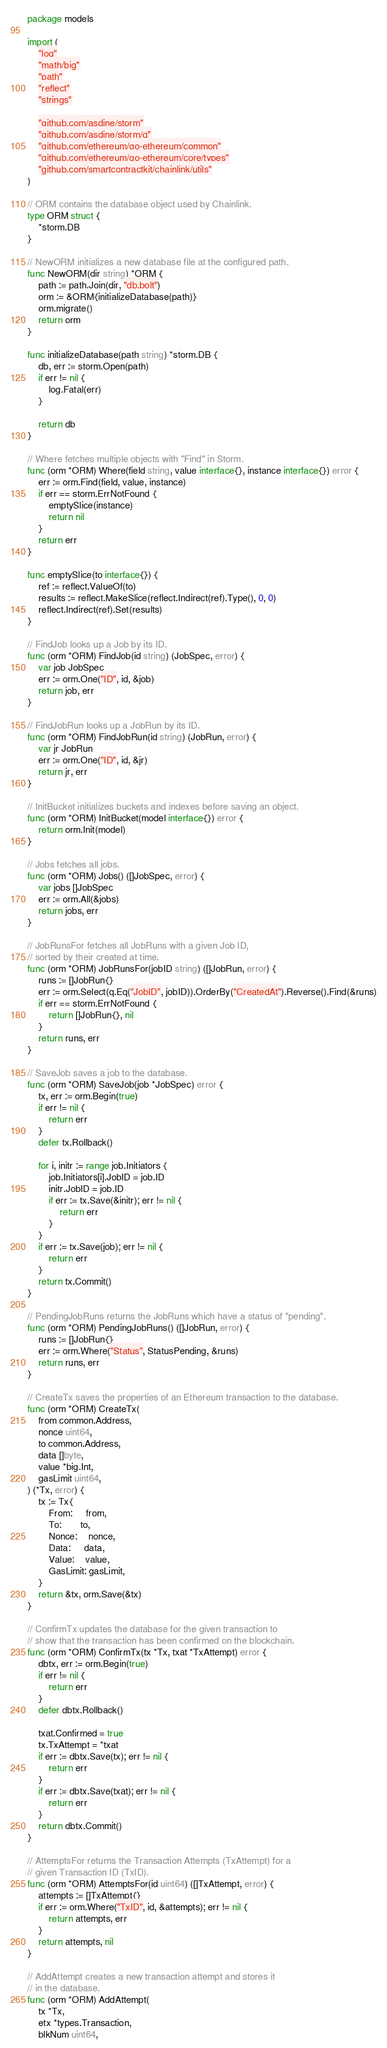Convert code to text. <code><loc_0><loc_0><loc_500><loc_500><_Go_>package models

import (
	"log"
	"math/big"
	"path"
	"reflect"
	"strings"

	"github.com/asdine/storm"
	"github.com/asdine/storm/q"
	"github.com/ethereum/go-ethereum/common"
	"github.com/ethereum/go-ethereum/core/types"
	"github.com/smartcontractkit/chainlink/utils"
)

// ORM contains the database object used by Chainlink.
type ORM struct {
	*storm.DB
}

// NewORM initializes a new database file at the configured path.
func NewORM(dir string) *ORM {
	path := path.Join(dir, "db.bolt")
	orm := &ORM{initializeDatabase(path)}
	orm.migrate()
	return orm
}

func initializeDatabase(path string) *storm.DB {
	db, err := storm.Open(path)
	if err != nil {
		log.Fatal(err)
	}

	return db
}

// Where fetches multiple objects with "Find" in Storm.
func (orm *ORM) Where(field string, value interface{}, instance interface{}) error {
	err := orm.Find(field, value, instance)
	if err == storm.ErrNotFound {
		emptySlice(instance)
		return nil
	}
	return err
}

func emptySlice(to interface{}) {
	ref := reflect.ValueOf(to)
	results := reflect.MakeSlice(reflect.Indirect(ref).Type(), 0, 0)
	reflect.Indirect(ref).Set(results)
}

// FindJob looks up a Job by its ID.
func (orm *ORM) FindJob(id string) (JobSpec, error) {
	var job JobSpec
	err := orm.One("ID", id, &job)
	return job, err
}

// FindJobRun looks up a JobRun by its ID.
func (orm *ORM) FindJobRun(id string) (JobRun, error) {
	var jr JobRun
	err := orm.One("ID", id, &jr)
	return jr, err
}

// InitBucket initializes buckets and indexes before saving an object.
func (orm *ORM) InitBucket(model interface{}) error {
	return orm.Init(model)
}

// Jobs fetches all jobs.
func (orm *ORM) Jobs() ([]JobSpec, error) {
	var jobs []JobSpec
	err := orm.All(&jobs)
	return jobs, err
}

// JobRunsFor fetches all JobRuns with a given Job ID,
// sorted by their created at time.
func (orm *ORM) JobRunsFor(jobID string) ([]JobRun, error) {
	runs := []JobRun{}
	err := orm.Select(q.Eq("JobID", jobID)).OrderBy("CreatedAt").Reverse().Find(&runs)
	if err == storm.ErrNotFound {
		return []JobRun{}, nil
	}
	return runs, err
}

// SaveJob saves a job to the database.
func (orm *ORM) SaveJob(job *JobSpec) error {
	tx, err := orm.Begin(true)
	if err != nil {
		return err
	}
	defer tx.Rollback()

	for i, initr := range job.Initiators {
		job.Initiators[i].JobID = job.ID
		initr.JobID = job.ID
		if err := tx.Save(&initr); err != nil {
			return err
		}
	}
	if err := tx.Save(job); err != nil {
		return err
	}
	return tx.Commit()
}

// PendingJobRuns returns the JobRuns which have a status of "pending".
func (orm *ORM) PendingJobRuns() ([]JobRun, error) {
	runs := []JobRun{}
	err := orm.Where("Status", StatusPending, &runs)
	return runs, err
}

// CreateTx saves the properties of an Ethereum transaction to the database.
func (orm *ORM) CreateTx(
	from common.Address,
	nonce uint64,
	to common.Address,
	data []byte,
	value *big.Int,
	gasLimit uint64,
) (*Tx, error) {
	tx := Tx{
		From:     from,
		To:       to,
		Nonce:    nonce,
		Data:     data,
		Value:    value,
		GasLimit: gasLimit,
	}
	return &tx, orm.Save(&tx)
}

// ConfirmTx updates the database for the given transaction to
// show that the transaction has been confirmed on the blockchain.
func (orm *ORM) ConfirmTx(tx *Tx, txat *TxAttempt) error {
	dbtx, err := orm.Begin(true)
	if err != nil {
		return err
	}
	defer dbtx.Rollback()

	txat.Confirmed = true
	tx.TxAttempt = *txat
	if err := dbtx.Save(tx); err != nil {
		return err
	}
	if err := dbtx.Save(txat); err != nil {
		return err
	}
	return dbtx.Commit()
}

// AttemptsFor returns the Transaction Attempts (TxAttempt) for a
// given Transaction ID (TxID).
func (orm *ORM) AttemptsFor(id uint64) ([]TxAttempt, error) {
	attempts := []TxAttempt{}
	if err := orm.Where("TxID", id, &attempts); err != nil {
		return attempts, err
	}
	return attempts, nil
}

// AddAttempt creates a new transaction attempt and stores it
// in the database.
func (orm *ORM) AddAttempt(
	tx *Tx,
	etx *types.Transaction,
	blkNum uint64,</code> 